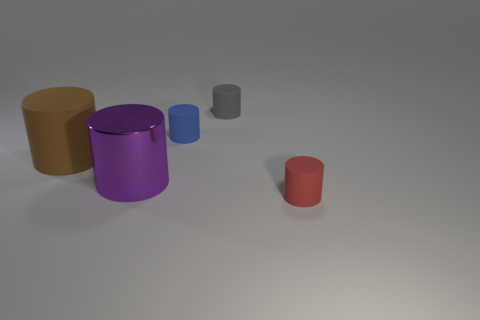What is the size of the matte cylinder in front of the large object behind the large purple thing?
Your answer should be compact. Small. The matte object that is both right of the large brown thing and in front of the blue cylinder is what color?
Offer a very short reply. Red. Is the shape of the small red matte object the same as the blue matte object?
Provide a short and direct response. Yes. The tiny object that is in front of the object that is on the left side of the large purple metallic cylinder is what shape?
Your response must be concise. Cylinder. Does the brown thing have the same shape as the matte thing that is in front of the purple metallic cylinder?
Your response must be concise. Yes. There is a metallic cylinder that is the same size as the brown matte cylinder; what is its color?
Offer a very short reply. Purple. Is the number of red things behind the big brown cylinder less than the number of tiny cylinders that are behind the large purple cylinder?
Keep it short and to the point. Yes. There is a matte object that is to the left of the small rubber cylinder left of the gray cylinder that is on the right side of the blue object; what shape is it?
Your answer should be very brief. Cylinder. Do the rubber object that is on the left side of the metallic cylinder and the matte cylinder that is on the right side of the gray object have the same color?
Offer a very short reply. No. How many shiny things are brown things or tiny gray cubes?
Offer a very short reply. 0. 